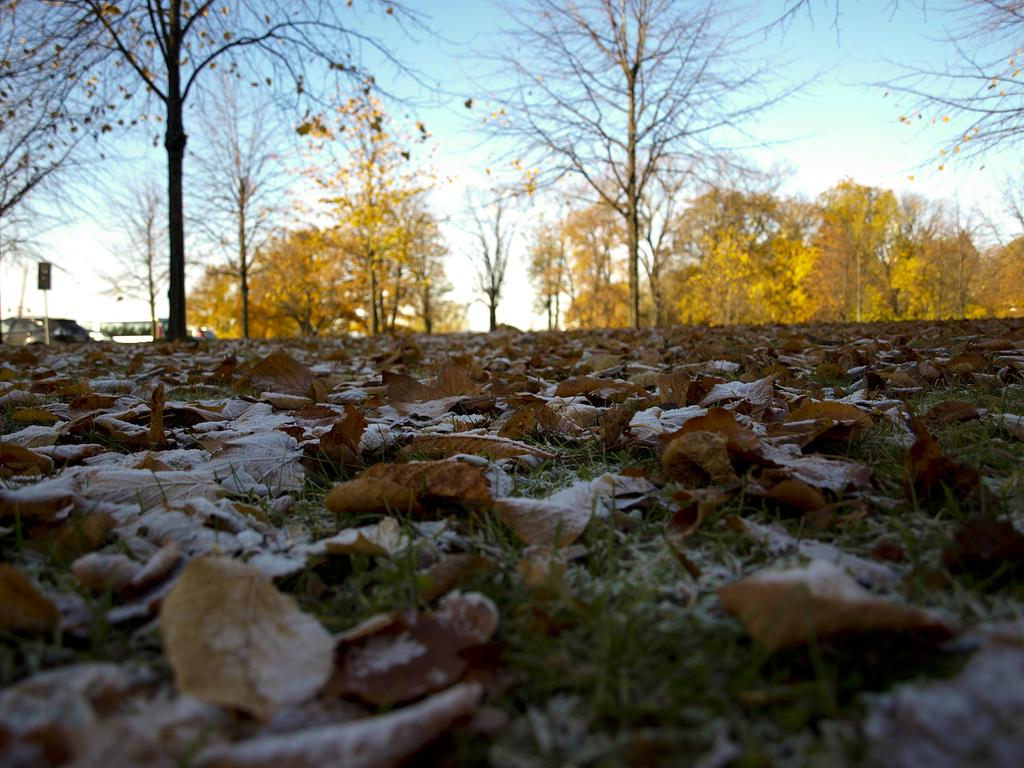What type of surface is visible in the image? There is a grass surface in the image. What can be found on the grass surface? There are dried leaves in the image. What can be seen in the distance beyond the grass surface? There are trees visible in the distance. What is visible above the grass surface and trees? The sky is visible in the image. What can be observed in the sky? Clouds are present in the sky. What type of print can be seen on the ducks in the image? There are no ducks present in the image, so there is no print to observe. 